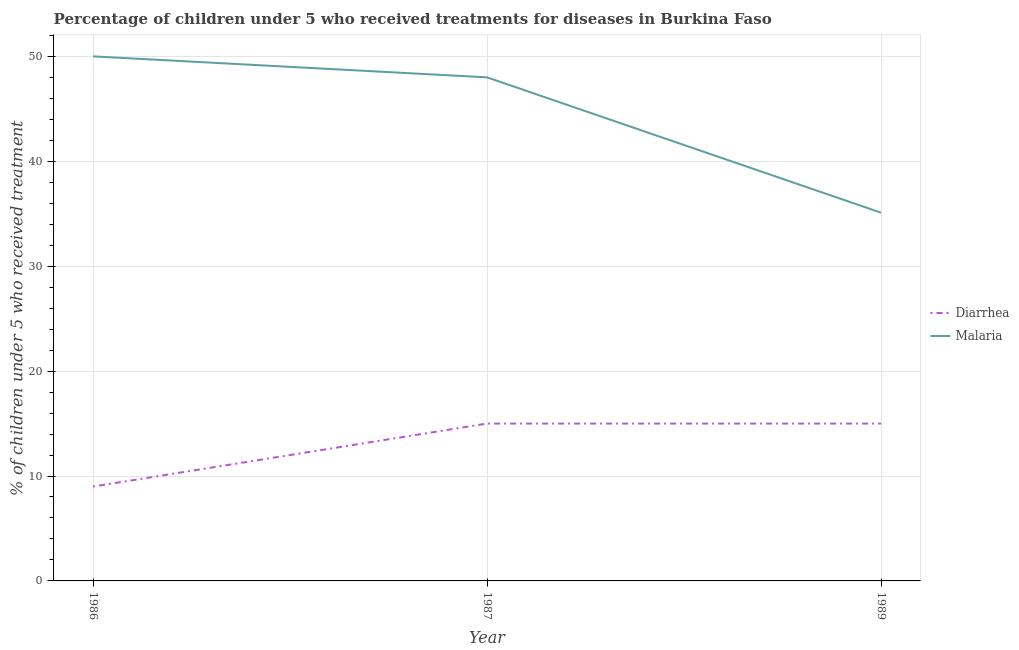How many different coloured lines are there?
Provide a short and direct response. 2. Does the line corresponding to percentage of children who received treatment for malaria intersect with the line corresponding to percentage of children who received treatment for diarrhoea?
Make the answer very short. No. Is the number of lines equal to the number of legend labels?
Provide a short and direct response. Yes. What is the percentage of children who received treatment for diarrhoea in 1986?
Your response must be concise. 9. Across all years, what is the maximum percentage of children who received treatment for diarrhoea?
Ensure brevity in your answer.  15. Across all years, what is the minimum percentage of children who received treatment for diarrhoea?
Give a very brief answer. 9. What is the total percentage of children who received treatment for malaria in the graph?
Your response must be concise. 133.1. What is the difference between the percentage of children who received treatment for diarrhoea in 1986 and that in 1989?
Give a very brief answer. -6. What is the average percentage of children who received treatment for malaria per year?
Offer a terse response. 44.37. In the year 1987, what is the difference between the percentage of children who received treatment for malaria and percentage of children who received treatment for diarrhoea?
Make the answer very short. 33. In how many years, is the percentage of children who received treatment for malaria greater than 26 %?
Your answer should be compact. 3. Is the percentage of children who received treatment for diarrhoea in 1986 less than that in 1987?
Provide a succinct answer. Yes. Is the difference between the percentage of children who received treatment for diarrhoea in 1987 and 1989 greater than the difference between the percentage of children who received treatment for malaria in 1987 and 1989?
Your response must be concise. No. What is the difference between the highest and the second highest percentage of children who received treatment for diarrhoea?
Your answer should be very brief. 0. What is the difference between the highest and the lowest percentage of children who received treatment for malaria?
Ensure brevity in your answer.  14.9. In how many years, is the percentage of children who received treatment for malaria greater than the average percentage of children who received treatment for malaria taken over all years?
Your answer should be very brief. 2. Is the sum of the percentage of children who received treatment for diarrhoea in 1986 and 1989 greater than the maximum percentage of children who received treatment for malaria across all years?
Your response must be concise. No. Does the percentage of children who received treatment for malaria monotonically increase over the years?
Keep it short and to the point. No. Is the percentage of children who received treatment for malaria strictly less than the percentage of children who received treatment for diarrhoea over the years?
Give a very brief answer. No. How many lines are there?
Give a very brief answer. 2. Does the graph contain grids?
Provide a short and direct response. Yes. Where does the legend appear in the graph?
Your response must be concise. Center right. How are the legend labels stacked?
Your answer should be compact. Vertical. What is the title of the graph?
Offer a terse response. Percentage of children under 5 who received treatments for diseases in Burkina Faso. Does "Malaria" appear as one of the legend labels in the graph?
Your response must be concise. Yes. What is the label or title of the Y-axis?
Your answer should be very brief. % of children under 5 who received treatment. What is the % of children under 5 who received treatment in Malaria in 1989?
Give a very brief answer. 35.1. Across all years, what is the maximum % of children under 5 who received treatment in Malaria?
Provide a short and direct response. 50. Across all years, what is the minimum % of children under 5 who received treatment of Malaria?
Provide a short and direct response. 35.1. What is the total % of children under 5 who received treatment of Malaria in the graph?
Your answer should be very brief. 133.1. What is the difference between the % of children under 5 who received treatment in Malaria in 1986 and that in 1989?
Ensure brevity in your answer.  14.9. What is the difference between the % of children under 5 who received treatment of Diarrhea in 1986 and the % of children under 5 who received treatment of Malaria in 1987?
Your answer should be compact. -39. What is the difference between the % of children under 5 who received treatment of Diarrhea in 1986 and the % of children under 5 who received treatment of Malaria in 1989?
Make the answer very short. -26.1. What is the difference between the % of children under 5 who received treatment of Diarrhea in 1987 and the % of children under 5 who received treatment of Malaria in 1989?
Give a very brief answer. -20.1. What is the average % of children under 5 who received treatment in Diarrhea per year?
Ensure brevity in your answer.  13. What is the average % of children under 5 who received treatment of Malaria per year?
Keep it short and to the point. 44.37. In the year 1986, what is the difference between the % of children under 5 who received treatment in Diarrhea and % of children under 5 who received treatment in Malaria?
Your answer should be compact. -41. In the year 1987, what is the difference between the % of children under 5 who received treatment in Diarrhea and % of children under 5 who received treatment in Malaria?
Provide a succinct answer. -33. In the year 1989, what is the difference between the % of children under 5 who received treatment in Diarrhea and % of children under 5 who received treatment in Malaria?
Give a very brief answer. -20.1. What is the ratio of the % of children under 5 who received treatment in Malaria in 1986 to that in 1987?
Make the answer very short. 1.04. What is the ratio of the % of children under 5 who received treatment of Malaria in 1986 to that in 1989?
Ensure brevity in your answer.  1.42. What is the ratio of the % of children under 5 who received treatment in Diarrhea in 1987 to that in 1989?
Offer a very short reply. 1. What is the ratio of the % of children under 5 who received treatment of Malaria in 1987 to that in 1989?
Your answer should be very brief. 1.37. What is the difference between the highest and the second highest % of children under 5 who received treatment of Malaria?
Make the answer very short. 2. What is the difference between the highest and the lowest % of children under 5 who received treatment in Malaria?
Make the answer very short. 14.9. 